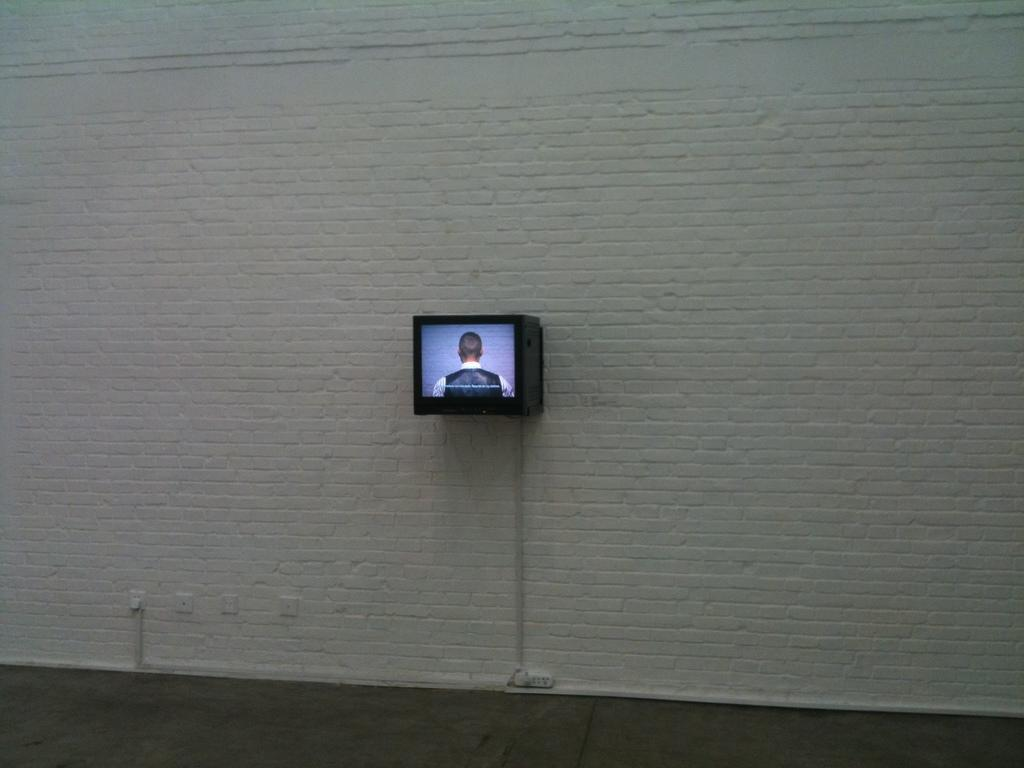What can be seen on the ground in the image? The ground is visible in the image, but there is no specific detail about what is on the ground. What color is the wall in the image? The wall in the image is white-colored. What is attached to the white wall? There is a black-colored screen attached to the wall. What is displayed on the screen? A person is displayed on the screen. Can you see a zephyr blowing through the image? There is no mention of a zephyr or any wind-related elements in the image. What type of offer is being made by the person on the screen? The image does not provide any information about an offer being made by the person on the screen. 